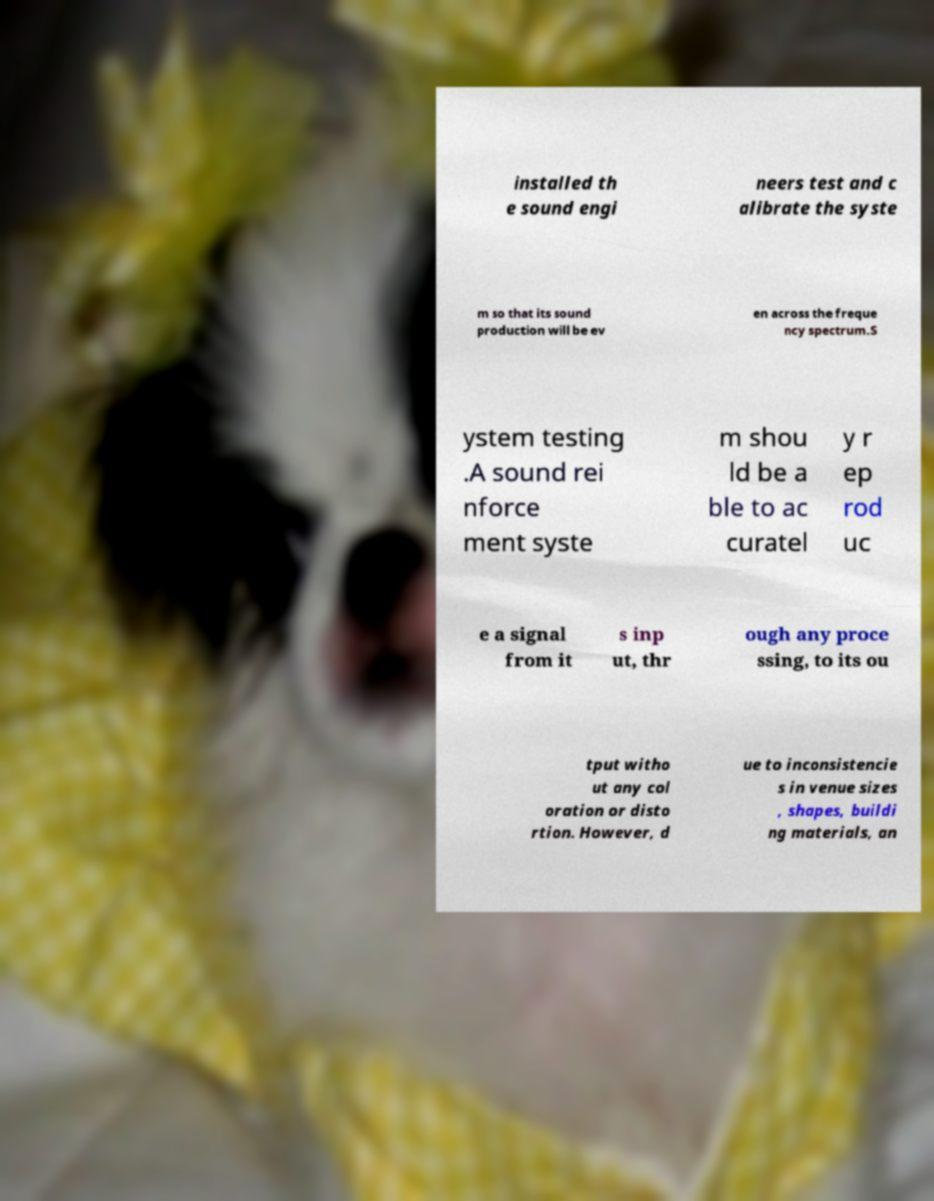Can you accurately transcribe the text from the provided image for me? installed th e sound engi neers test and c alibrate the syste m so that its sound production will be ev en across the freque ncy spectrum.S ystem testing .A sound rei nforce ment syste m shou ld be a ble to ac curatel y r ep rod uc e a signal from it s inp ut, thr ough any proce ssing, to its ou tput witho ut any col oration or disto rtion. However, d ue to inconsistencie s in venue sizes , shapes, buildi ng materials, an 